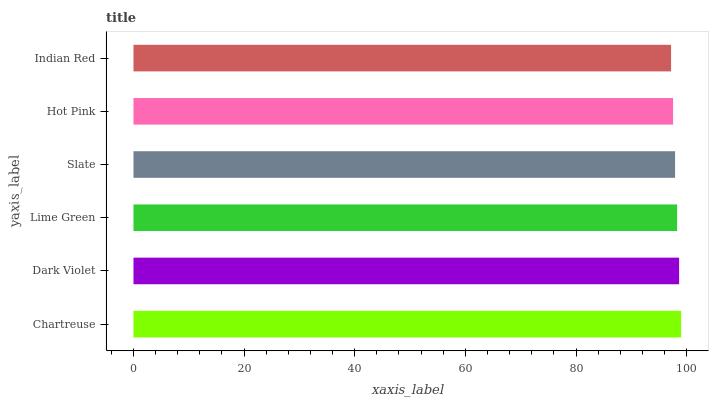Is Indian Red the minimum?
Answer yes or no. Yes. Is Chartreuse the maximum?
Answer yes or no. Yes. Is Dark Violet the minimum?
Answer yes or no. No. Is Dark Violet the maximum?
Answer yes or no. No. Is Chartreuse greater than Dark Violet?
Answer yes or no. Yes. Is Dark Violet less than Chartreuse?
Answer yes or no. Yes. Is Dark Violet greater than Chartreuse?
Answer yes or no. No. Is Chartreuse less than Dark Violet?
Answer yes or no. No. Is Lime Green the high median?
Answer yes or no. Yes. Is Slate the low median?
Answer yes or no. Yes. Is Hot Pink the high median?
Answer yes or no. No. Is Hot Pink the low median?
Answer yes or no. No. 